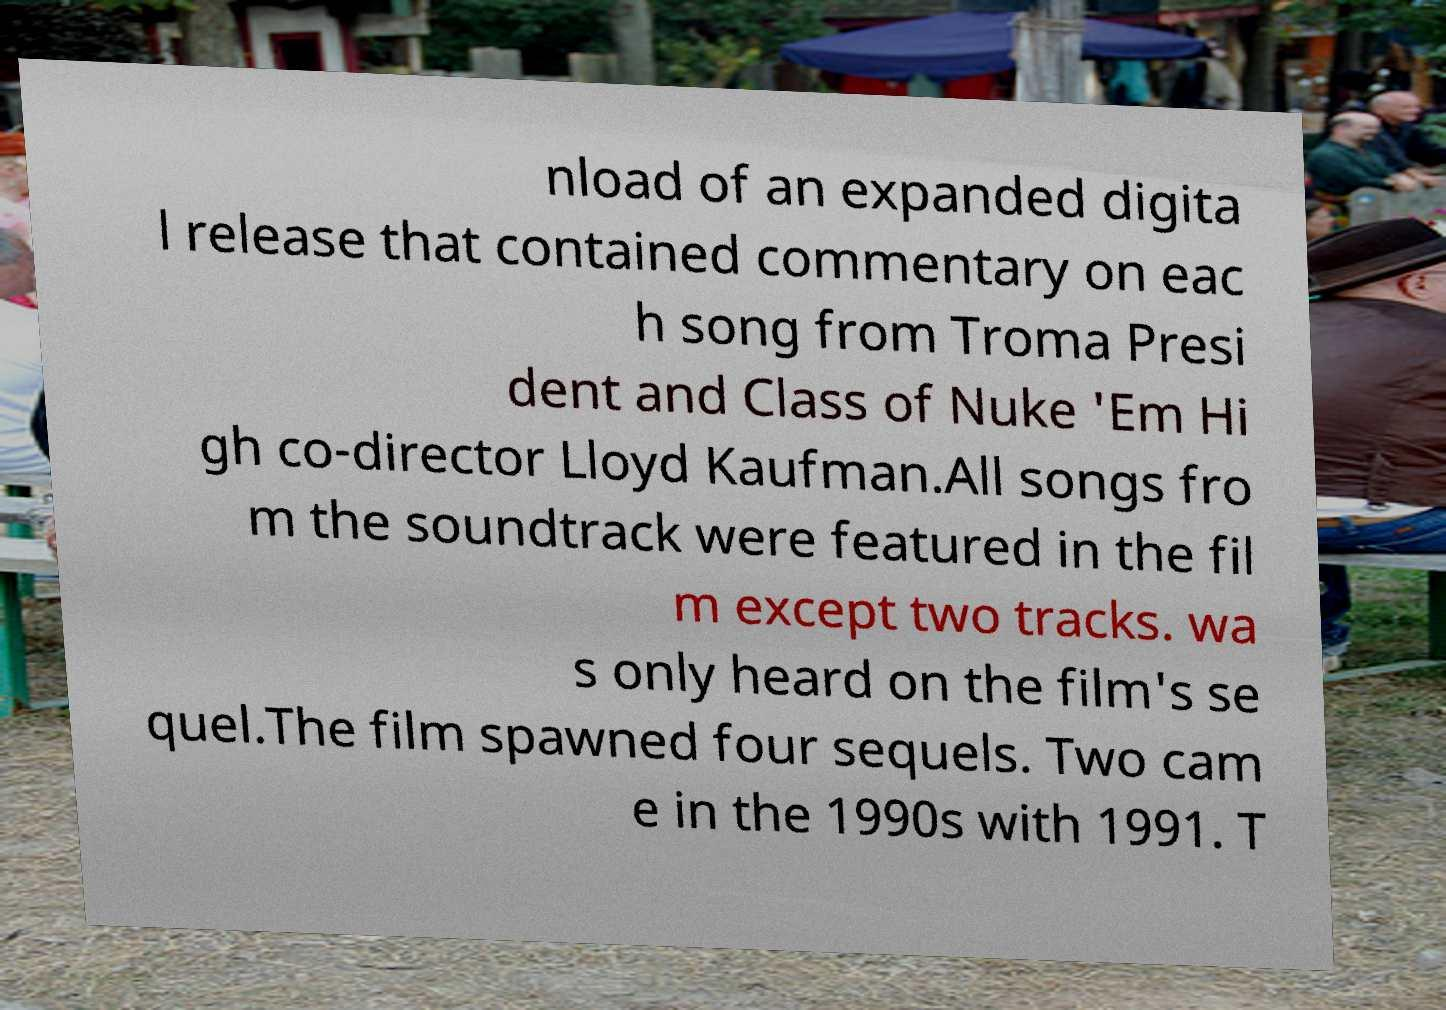There's text embedded in this image that I need extracted. Can you transcribe it verbatim? nload of an expanded digita l release that contained commentary on eac h song from Troma Presi dent and Class of Nuke 'Em Hi gh co-director Lloyd Kaufman.All songs fro m the soundtrack were featured in the fil m except two tracks. wa s only heard on the film's se quel.The film spawned four sequels. Two cam e in the 1990s with 1991. T 